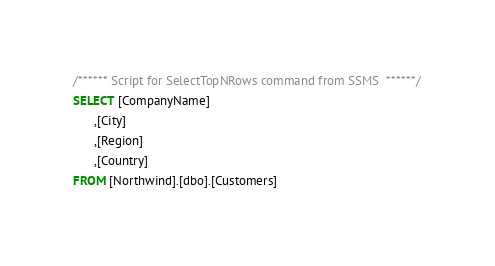<code> <loc_0><loc_0><loc_500><loc_500><_SQL_>/****** Script for SelectTopNRows command from SSMS  ******/
SELECT [CompanyName]
      ,[City]
      ,[Region]
      ,[Country]
FROM [Northwind].[dbo].[Customers]</code> 